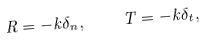Convert formula to latex. <formula><loc_0><loc_0><loc_500><loc_500>R = - k \delta _ { n } , \quad T = - k \delta _ { t } ,</formula> 